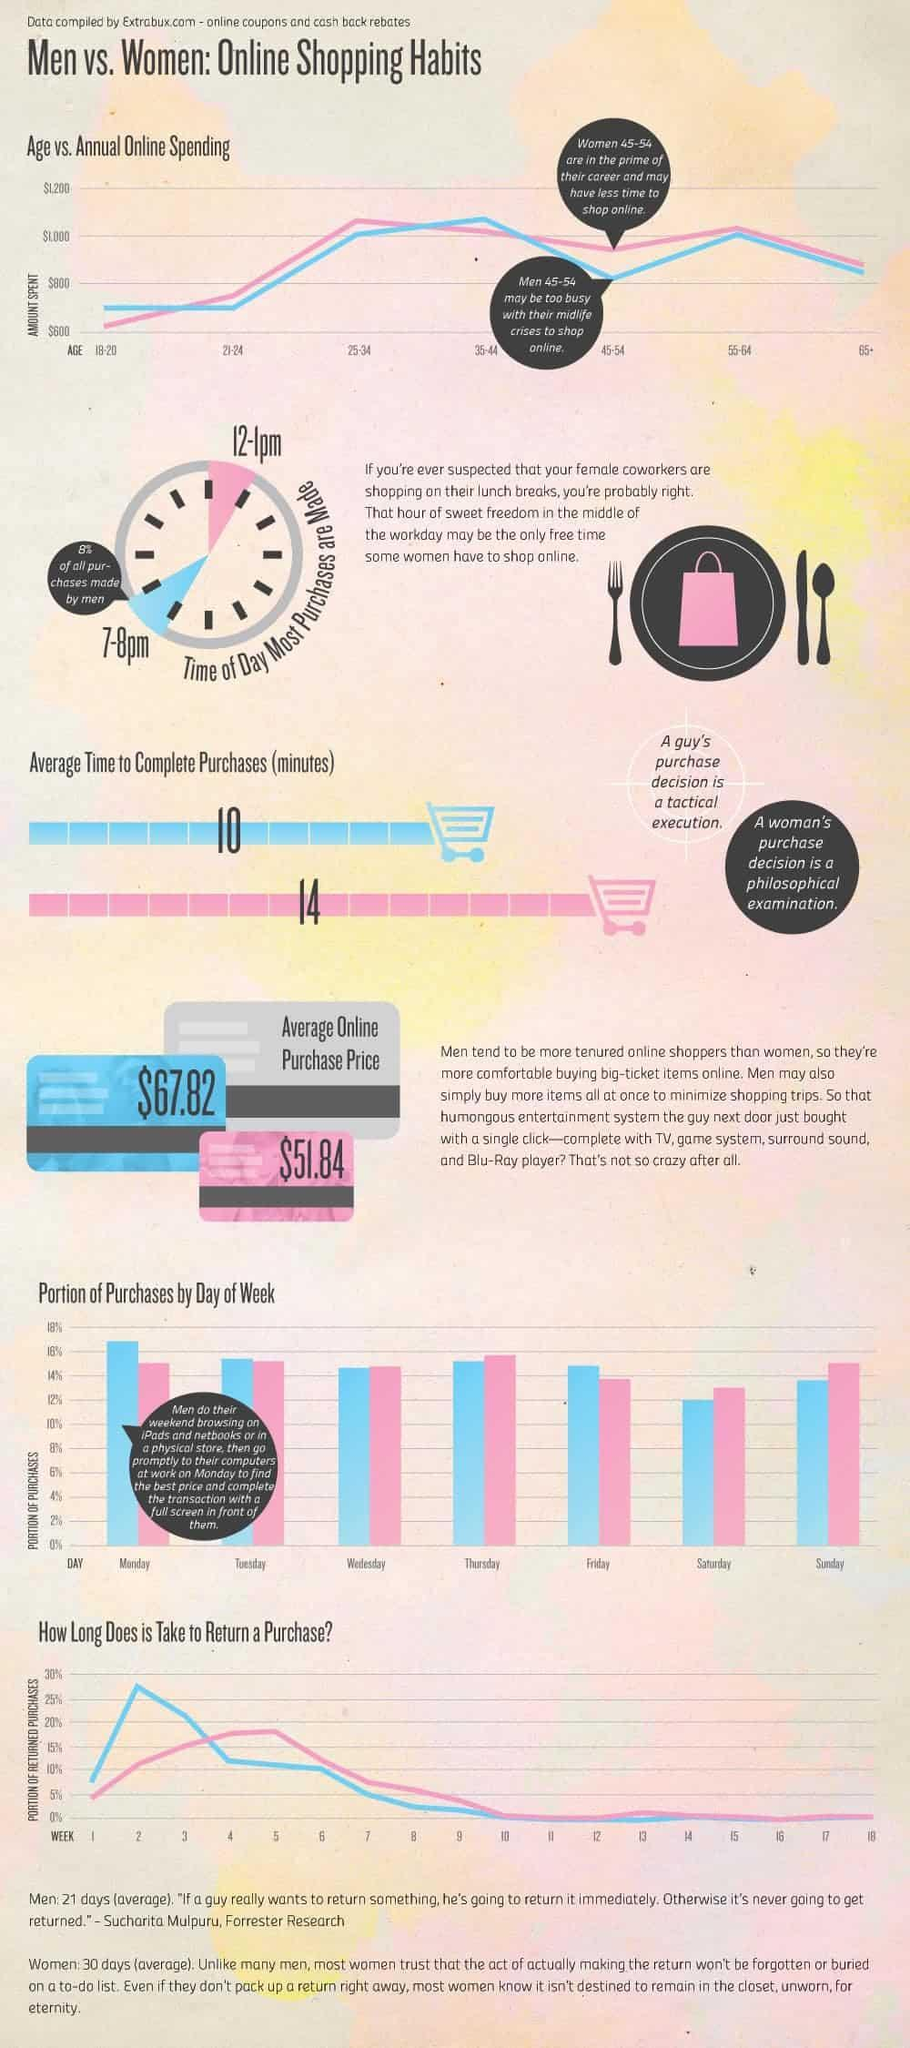What is the average time (in minutes) taken by men to complete online purchases?
Answer the question with a short phrase. 10 What time of the day did men make most of their online purchases? 7-8pm What time of the day did women make most of their online purchases? 12-1pm What is the average purchase price in online shopping by women? $51.84 What is the average time (in minutes) taken by women to complete online purchases? 14 Which age group of men spent more than $1,000 on online shopping annually? 35-44 